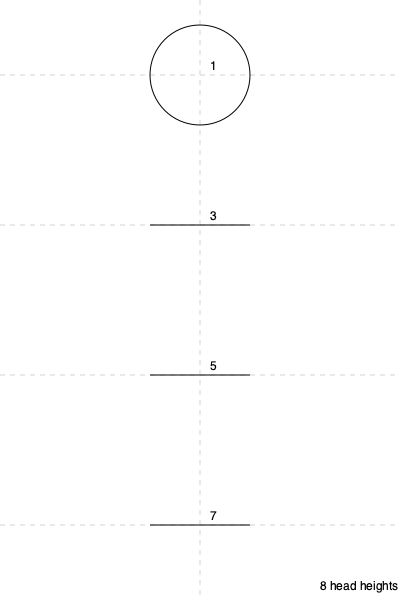In figure drawing, the "8-head" system is commonly used for proportioning the human body. According to this system, if the model's actual height is 68 inches, what would be the approximate height of the model's head in inches? To solve this problem, we'll follow these steps:

1. Understand the "8-head" system:
   - The total height of the figure is divided into 8 equal parts.
   - Each part is equal to the height of the head.

2. Calculate the height of one "head" unit:
   - Total height = 68 inches
   - Number of "head" units = 8
   - Height of one "head" unit = Total height ÷ Number of "head" units
   - Height of one "head" unit = 68 ÷ 8

3. Perform the calculation:
   $$ \text{Head height} = \frac{68 \text{ inches}}{8} = 8.5 \text{ inches} $$

Therefore, the approximate height of the model's head would be 8.5 inches.
Answer: 8.5 inches 